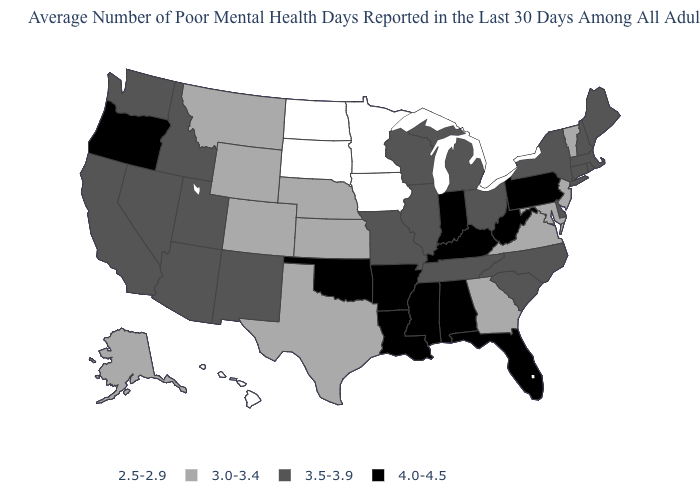What is the value of Utah?
Write a very short answer. 3.5-3.9. Which states hav the highest value in the West?
Answer briefly. Oregon. What is the value of New Hampshire?
Short answer required. 3.5-3.9. What is the lowest value in the USA?
Quick response, please. 2.5-2.9. Does the first symbol in the legend represent the smallest category?
Answer briefly. Yes. Which states have the highest value in the USA?
Give a very brief answer. Alabama, Arkansas, Florida, Indiana, Kentucky, Louisiana, Mississippi, Oklahoma, Oregon, Pennsylvania, West Virginia. What is the value of Arizona?
Be succinct. 3.5-3.9. Does California have a lower value than West Virginia?
Be succinct. Yes. Name the states that have a value in the range 2.5-2.9?
Short answer required. Hawaii, Iowa, Minnesota, North Dakota, South Dakota. Name the states that have a value in the range 2.5-2.9?
Answer briefly. Hawaii, Iowa, Minnesota, North Dakota, South Dakota. Is the legend a continuous bar?
Keep it brief. No. What is the value of Oklahoma?
Write a very short answer. 4.0-4.5. Among the states that border Missouri , does Nebraska have the lowest value?
Short answer required. No. What is the value of Rhode Island?
Be succinct. 3.5-3.9. Does Indiana have the highest value in the MidWest?
Short answer required. Yes. 